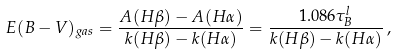Convert formula to latex. <formula><loc_0><loc_0><loc_500><loc_500>E ( B - V ) _ { g a s } = \frac { A ( H \beta ) - A ( H \alpha ) } { k ( H \beta ) - k ( H \alpha ) } = \frac { 1 . 0 8 6 \tau _ { B } ^ { l } } { k ( H \beta ) - k ( H \alpha ) } \, ,</formula> 